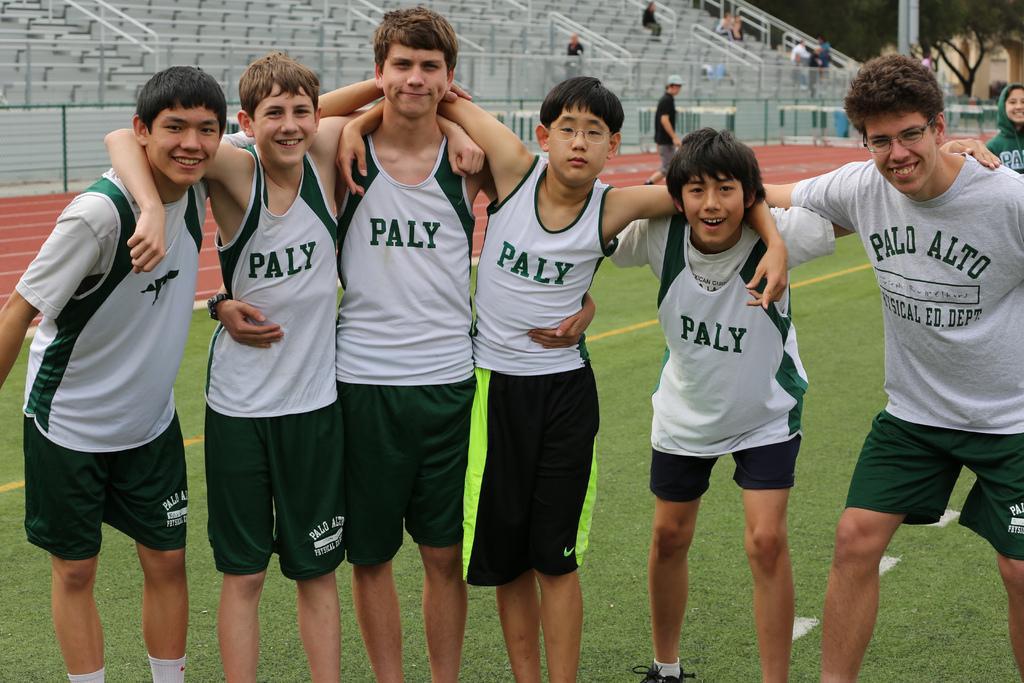How would you summarize this image in a sentence or two? In this image, we can see a group of people are standing and watching. Few people are smiling. Background we can see people, stadium, fence, rods, trees and pole. 